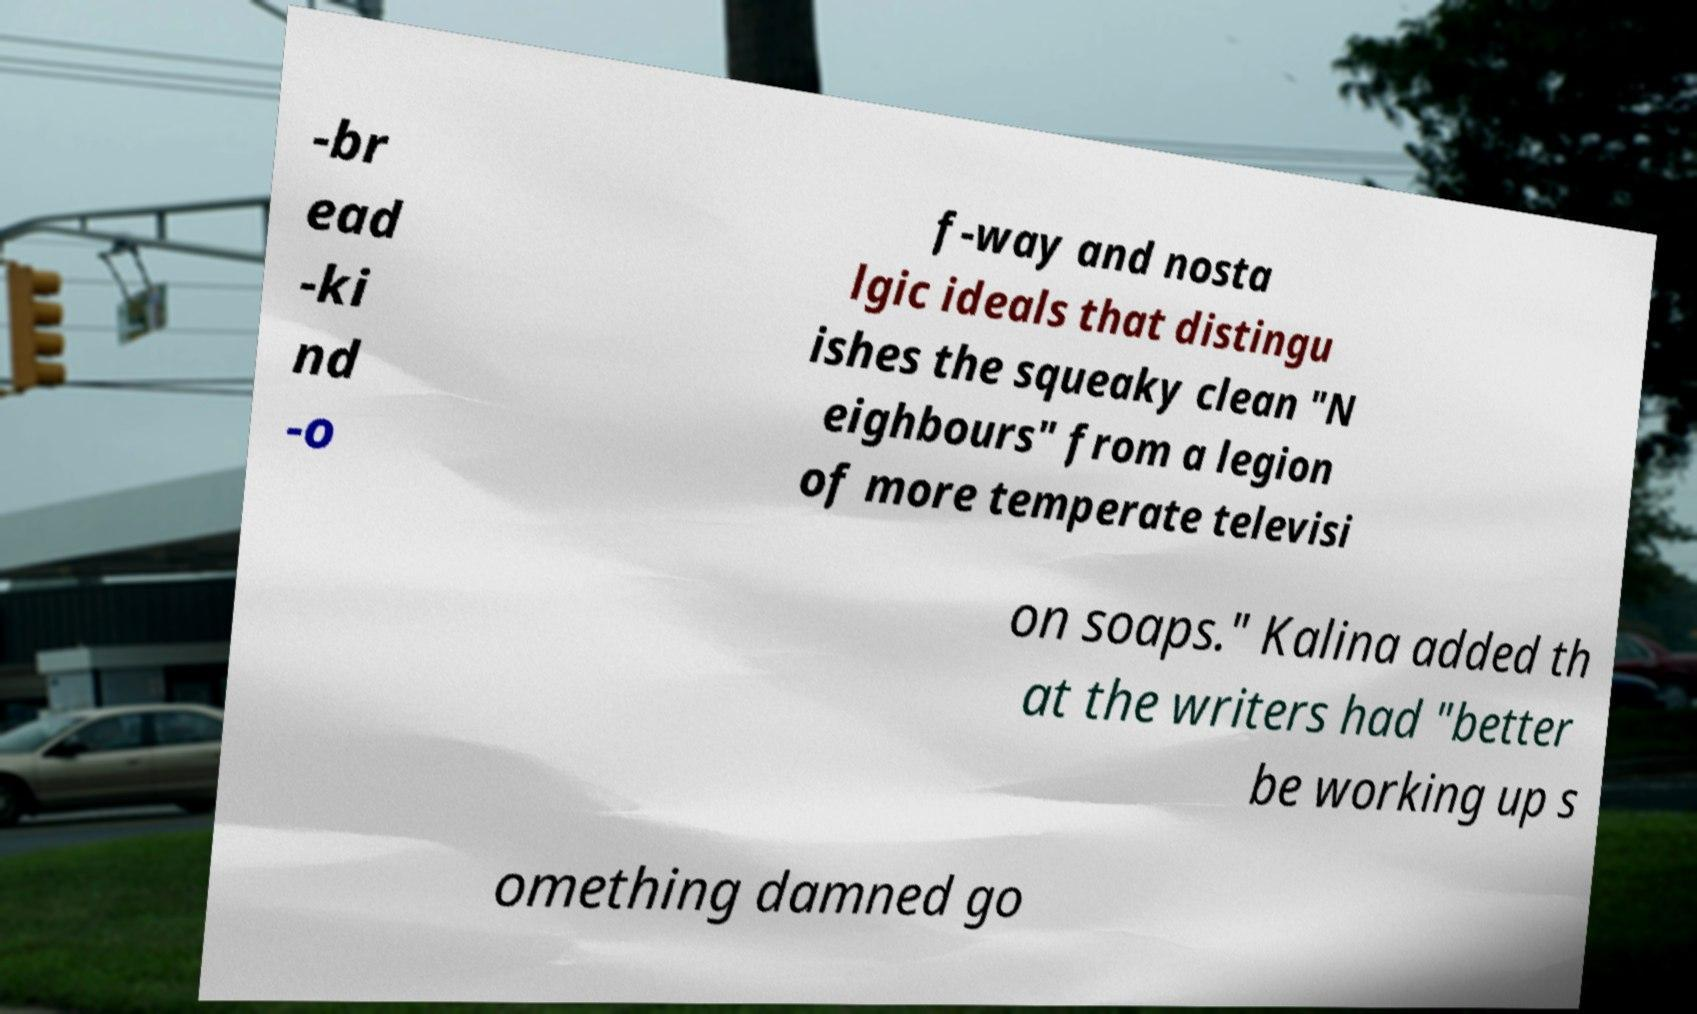Could you assist in decoding the text presented in this image and type it out clearly? -br ead -ki nd -o f-way and nosta lgic ideals that distingu ishes the squeaky clean "N eighbours" from a legion of more temperate televisi on soaps." Kalina added th at the writers had "better be working up s omething damned go 